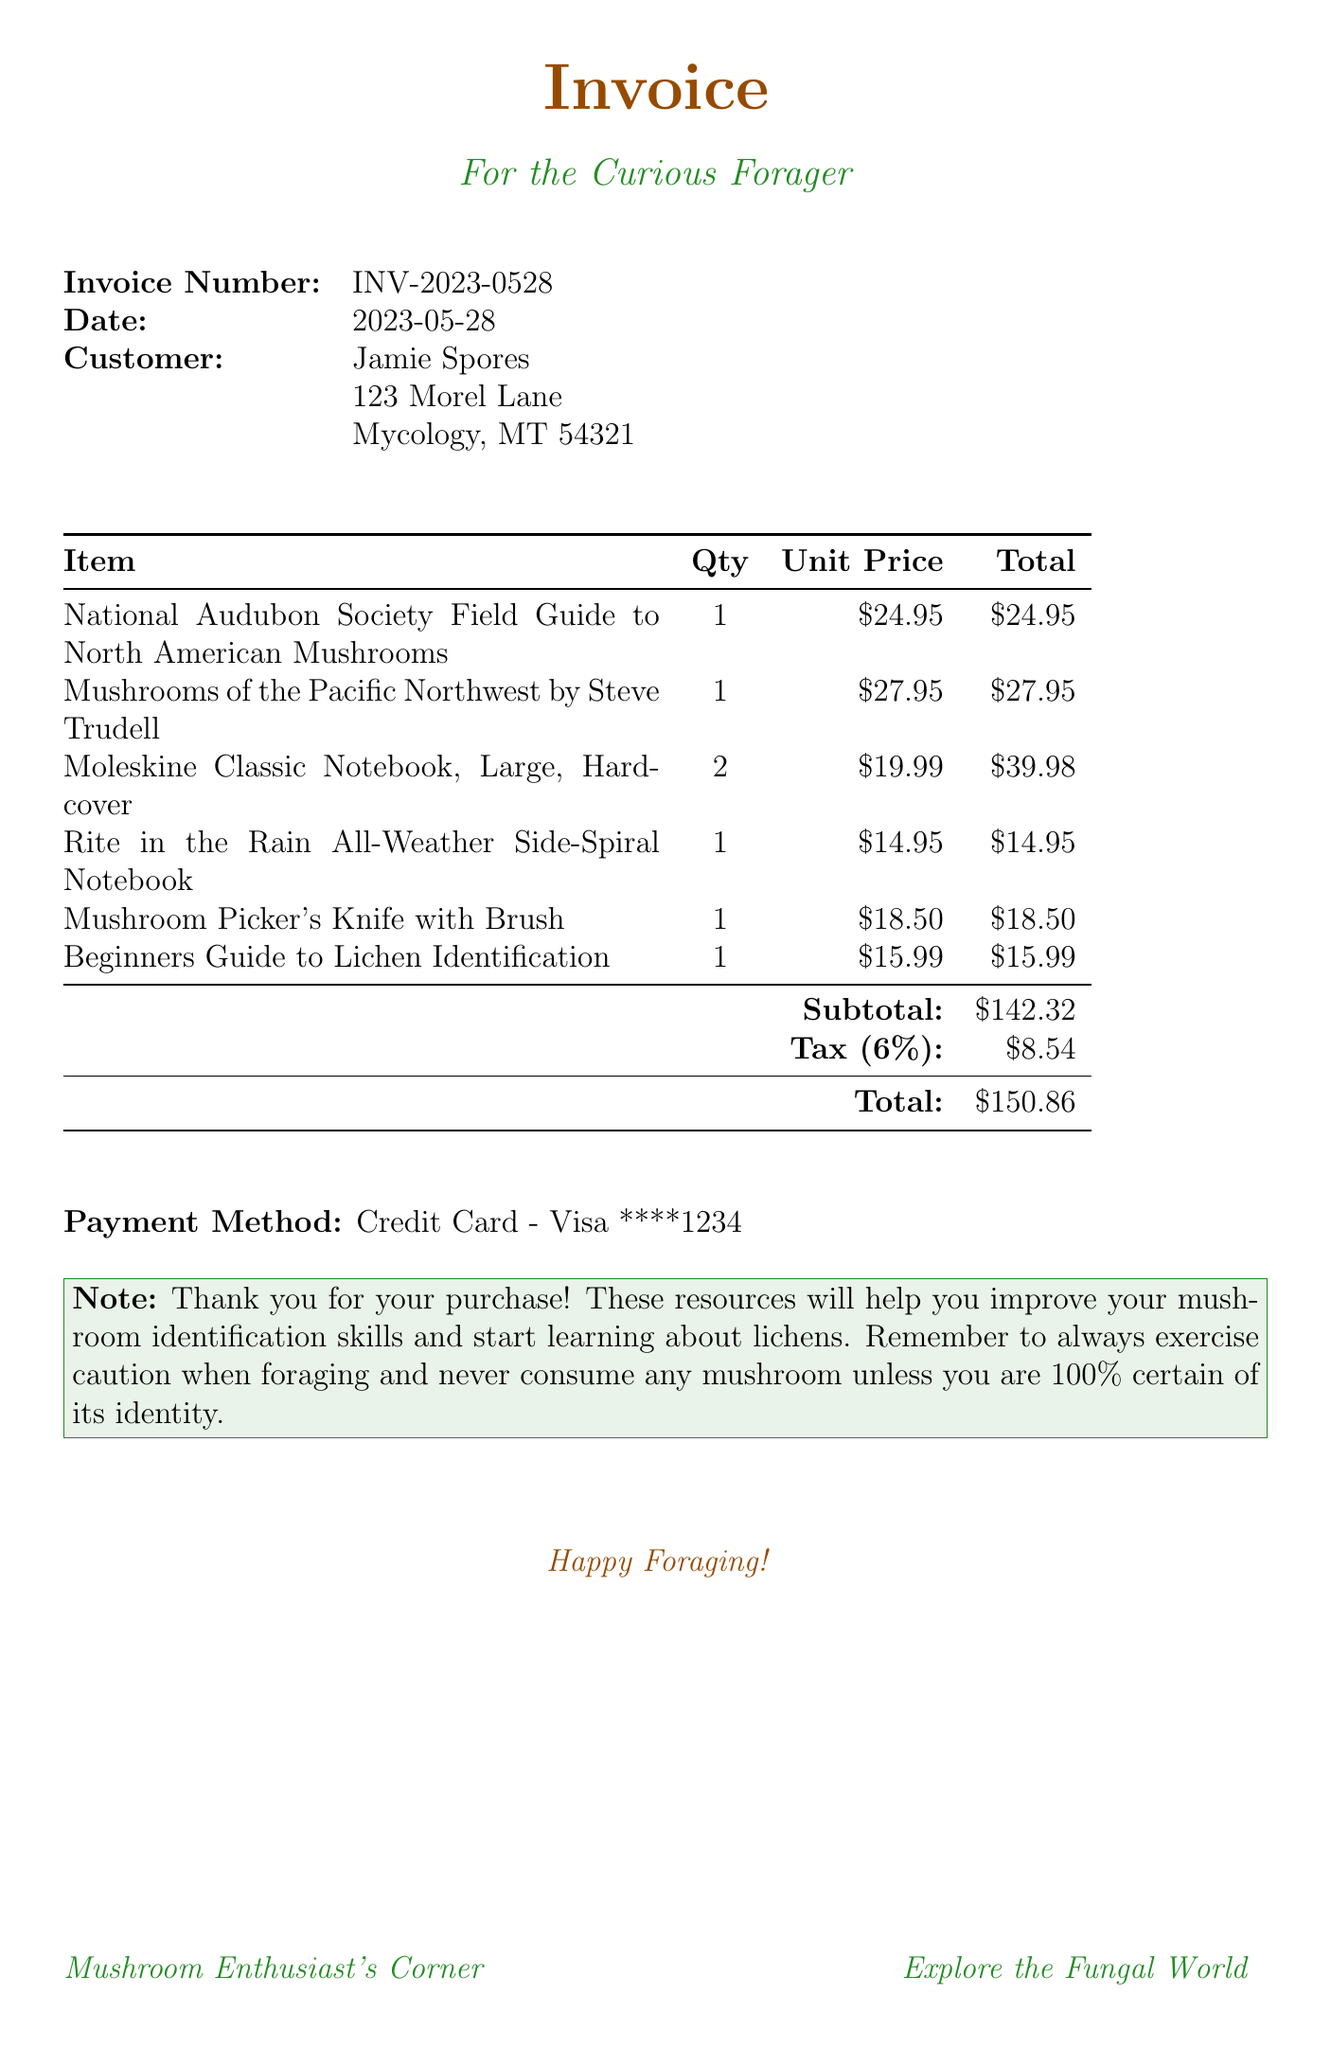What is the invoice number? The invoice number is a specific identifier for this purchase, which is detailed in the document.
Answer: INV-2023-0528 What is the date of the invoice? The date indicates when the invoice was generated, which is found in the document.
Answer: 2023-05-28 Who is the customer? The customer's name is provided for billing purposes within the invoice.
Answer: Jamie Spores What is the total amount due? The total amount includes the subtotal and tax as calculated in the document.
Answer: $150.86 How many Moleskine Classic Notebooks were purchased? The quantity of this item shows how many were included in the purchase on the invoice.
Answer: 2 What is the tax rate applied to the invoice? The document indicates the tax percentage added to the subtotal.
Answer: 6% What is the payment method used? The payment method details how the customer paid for the items on the invoice.
Answer: Credit Card - Visa ****1234 What is the subtotal before tax? The subtotal represents the total cost of items before any tax is applied.
Answer: $142.32 What item is specifically related to lichen identification? This question targets the item purchased that focuses on lichens, mentioned in the document.
Answer: Beginners Guide to Lichen Identification Why should one exercise caution when foraging? The note section of the invoice emphasizes safety while foraging, indicating a reasoning beyond the item details.
Answer: To avoid consuming uncertain mushrooms 